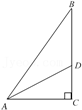Narrate what you see in the visual. The image shows a right triangle labeled ABC, where angle C is a right angle. Point D lies on the hypotenuse AB, and AD intersects BC at D. Additionally, a line segment DE is drawn from D to AB and is perpendicular to AB, forming smaller segments and angles within the triangle. Such geometric configurations are fundamental in exploring properties related to angles, triangles, and the Pythagorean theorem, important in various fields of mathematics and physics. 